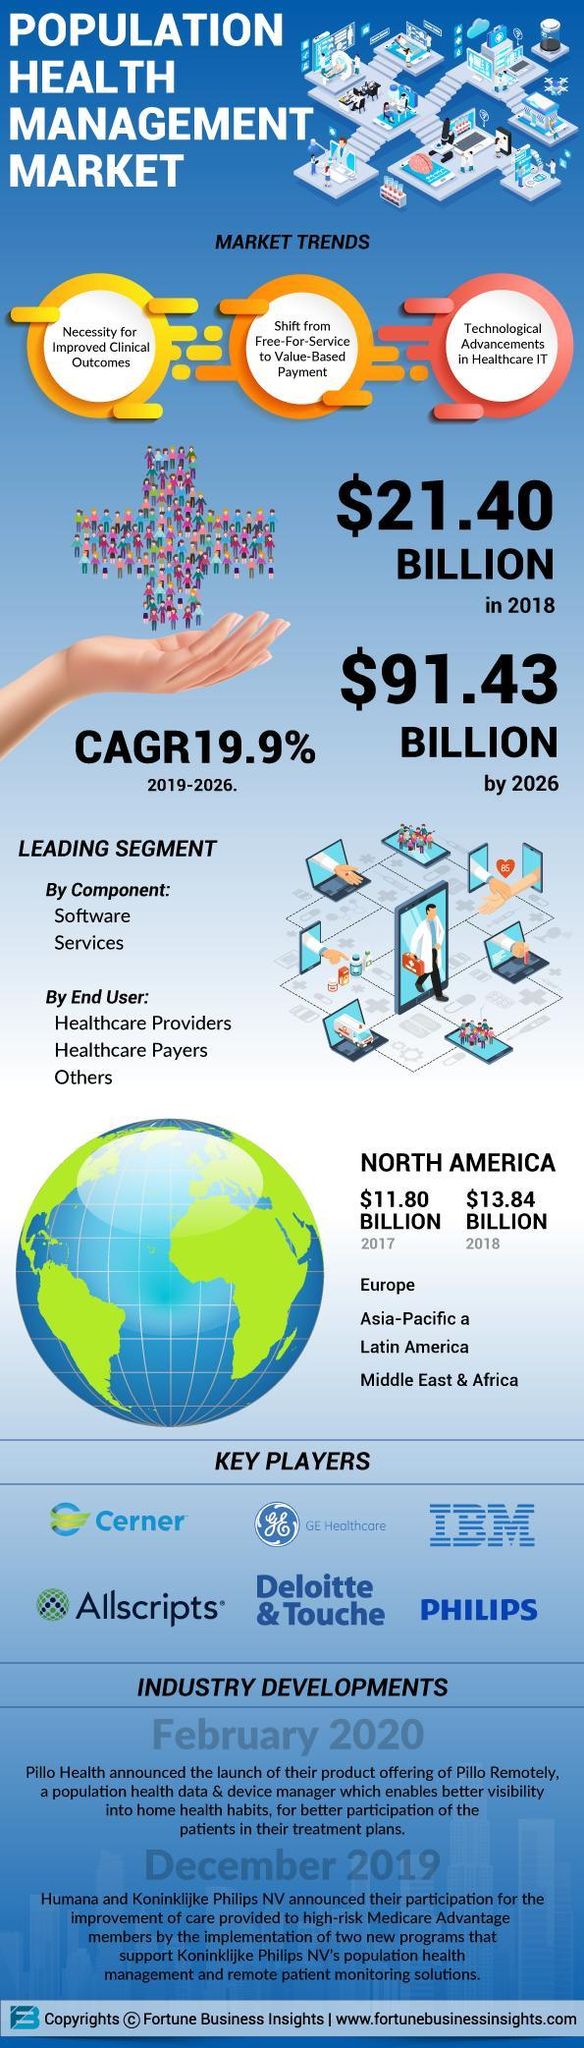What is the number of key players mentioned in this infographic?
Answer the question with a short phrase. 6 